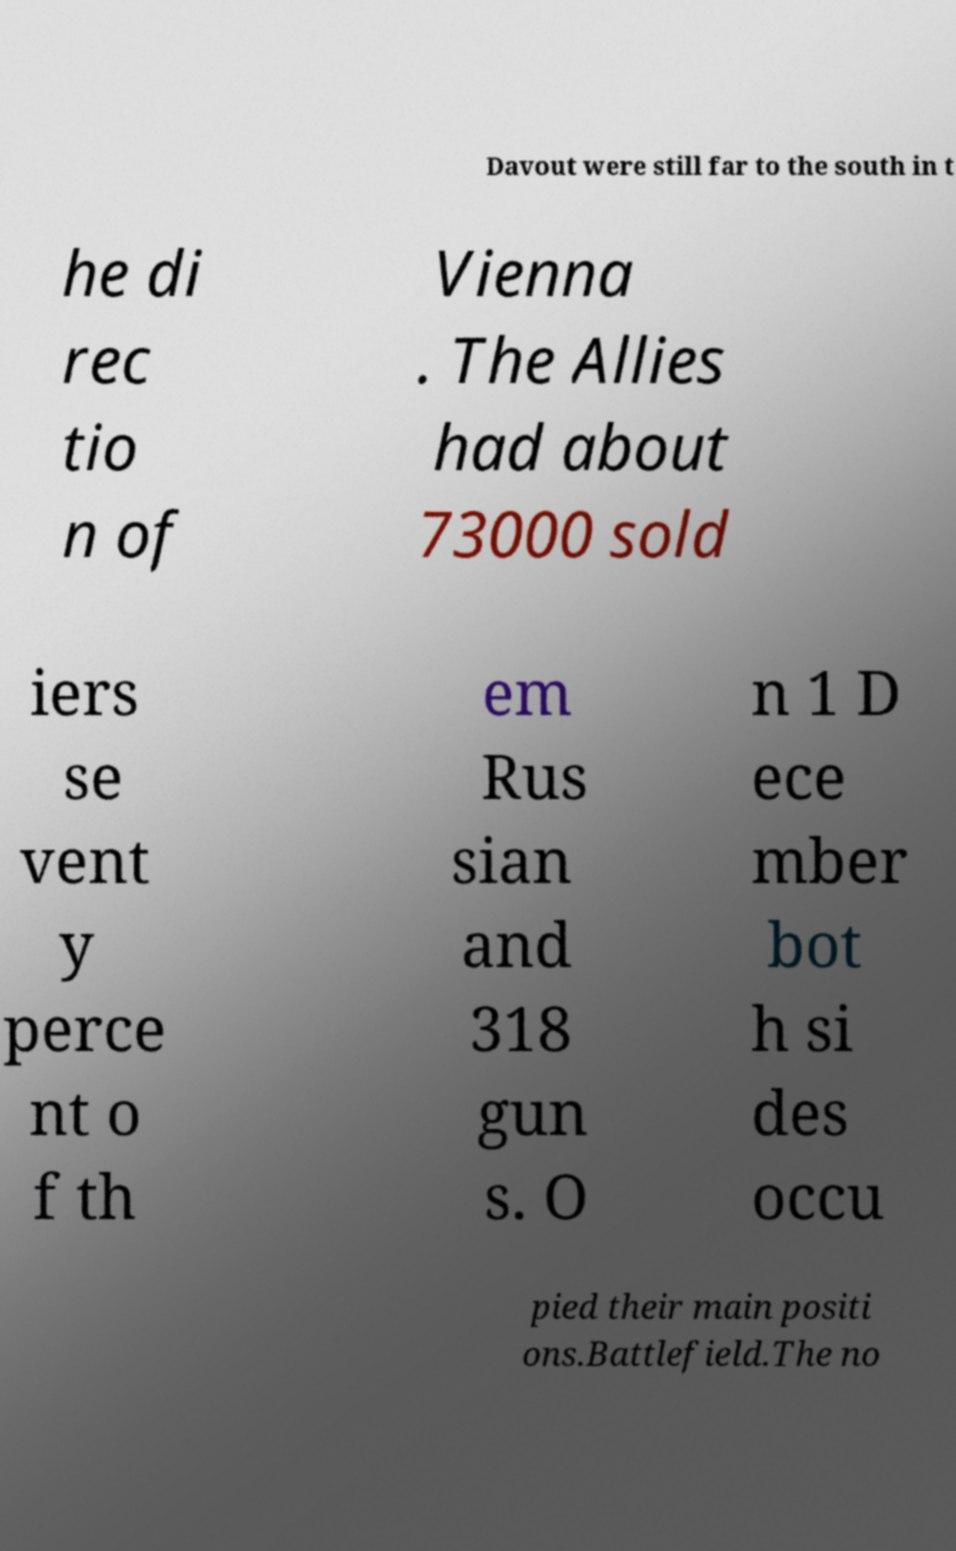For documentation purposes, I need the text within this image transcribed. Could you provide that? Davout were still far to the south in t he di rec tio n of Vienna . The Allies had about 73000 sold iers se vent y perce nt o f th em Rus sian and 318 gun s. O n 1 D ece mber bot h si des occu pied their main positi ons.Battlefield.The no 